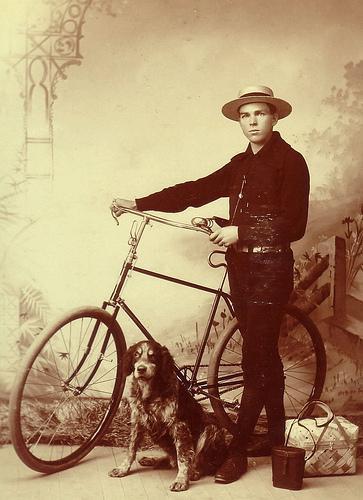How many people are in the picture?
Give a very brief answer. 1. 